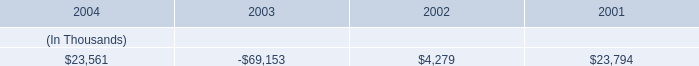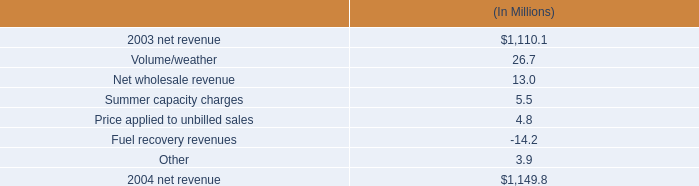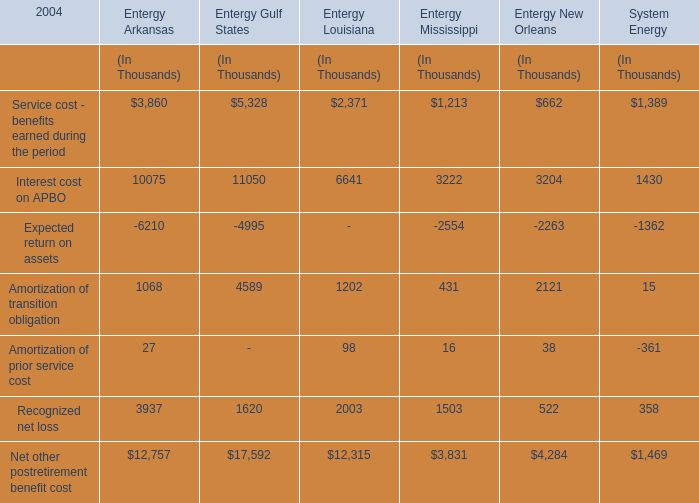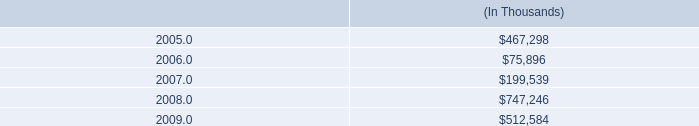What's the total value of all Entergy Gulf States that are smaller than 7000 in 2004? (in million) 
Computations: (((5328 - 4995) + 4589) + 1620)
Answer: 6542.0. 